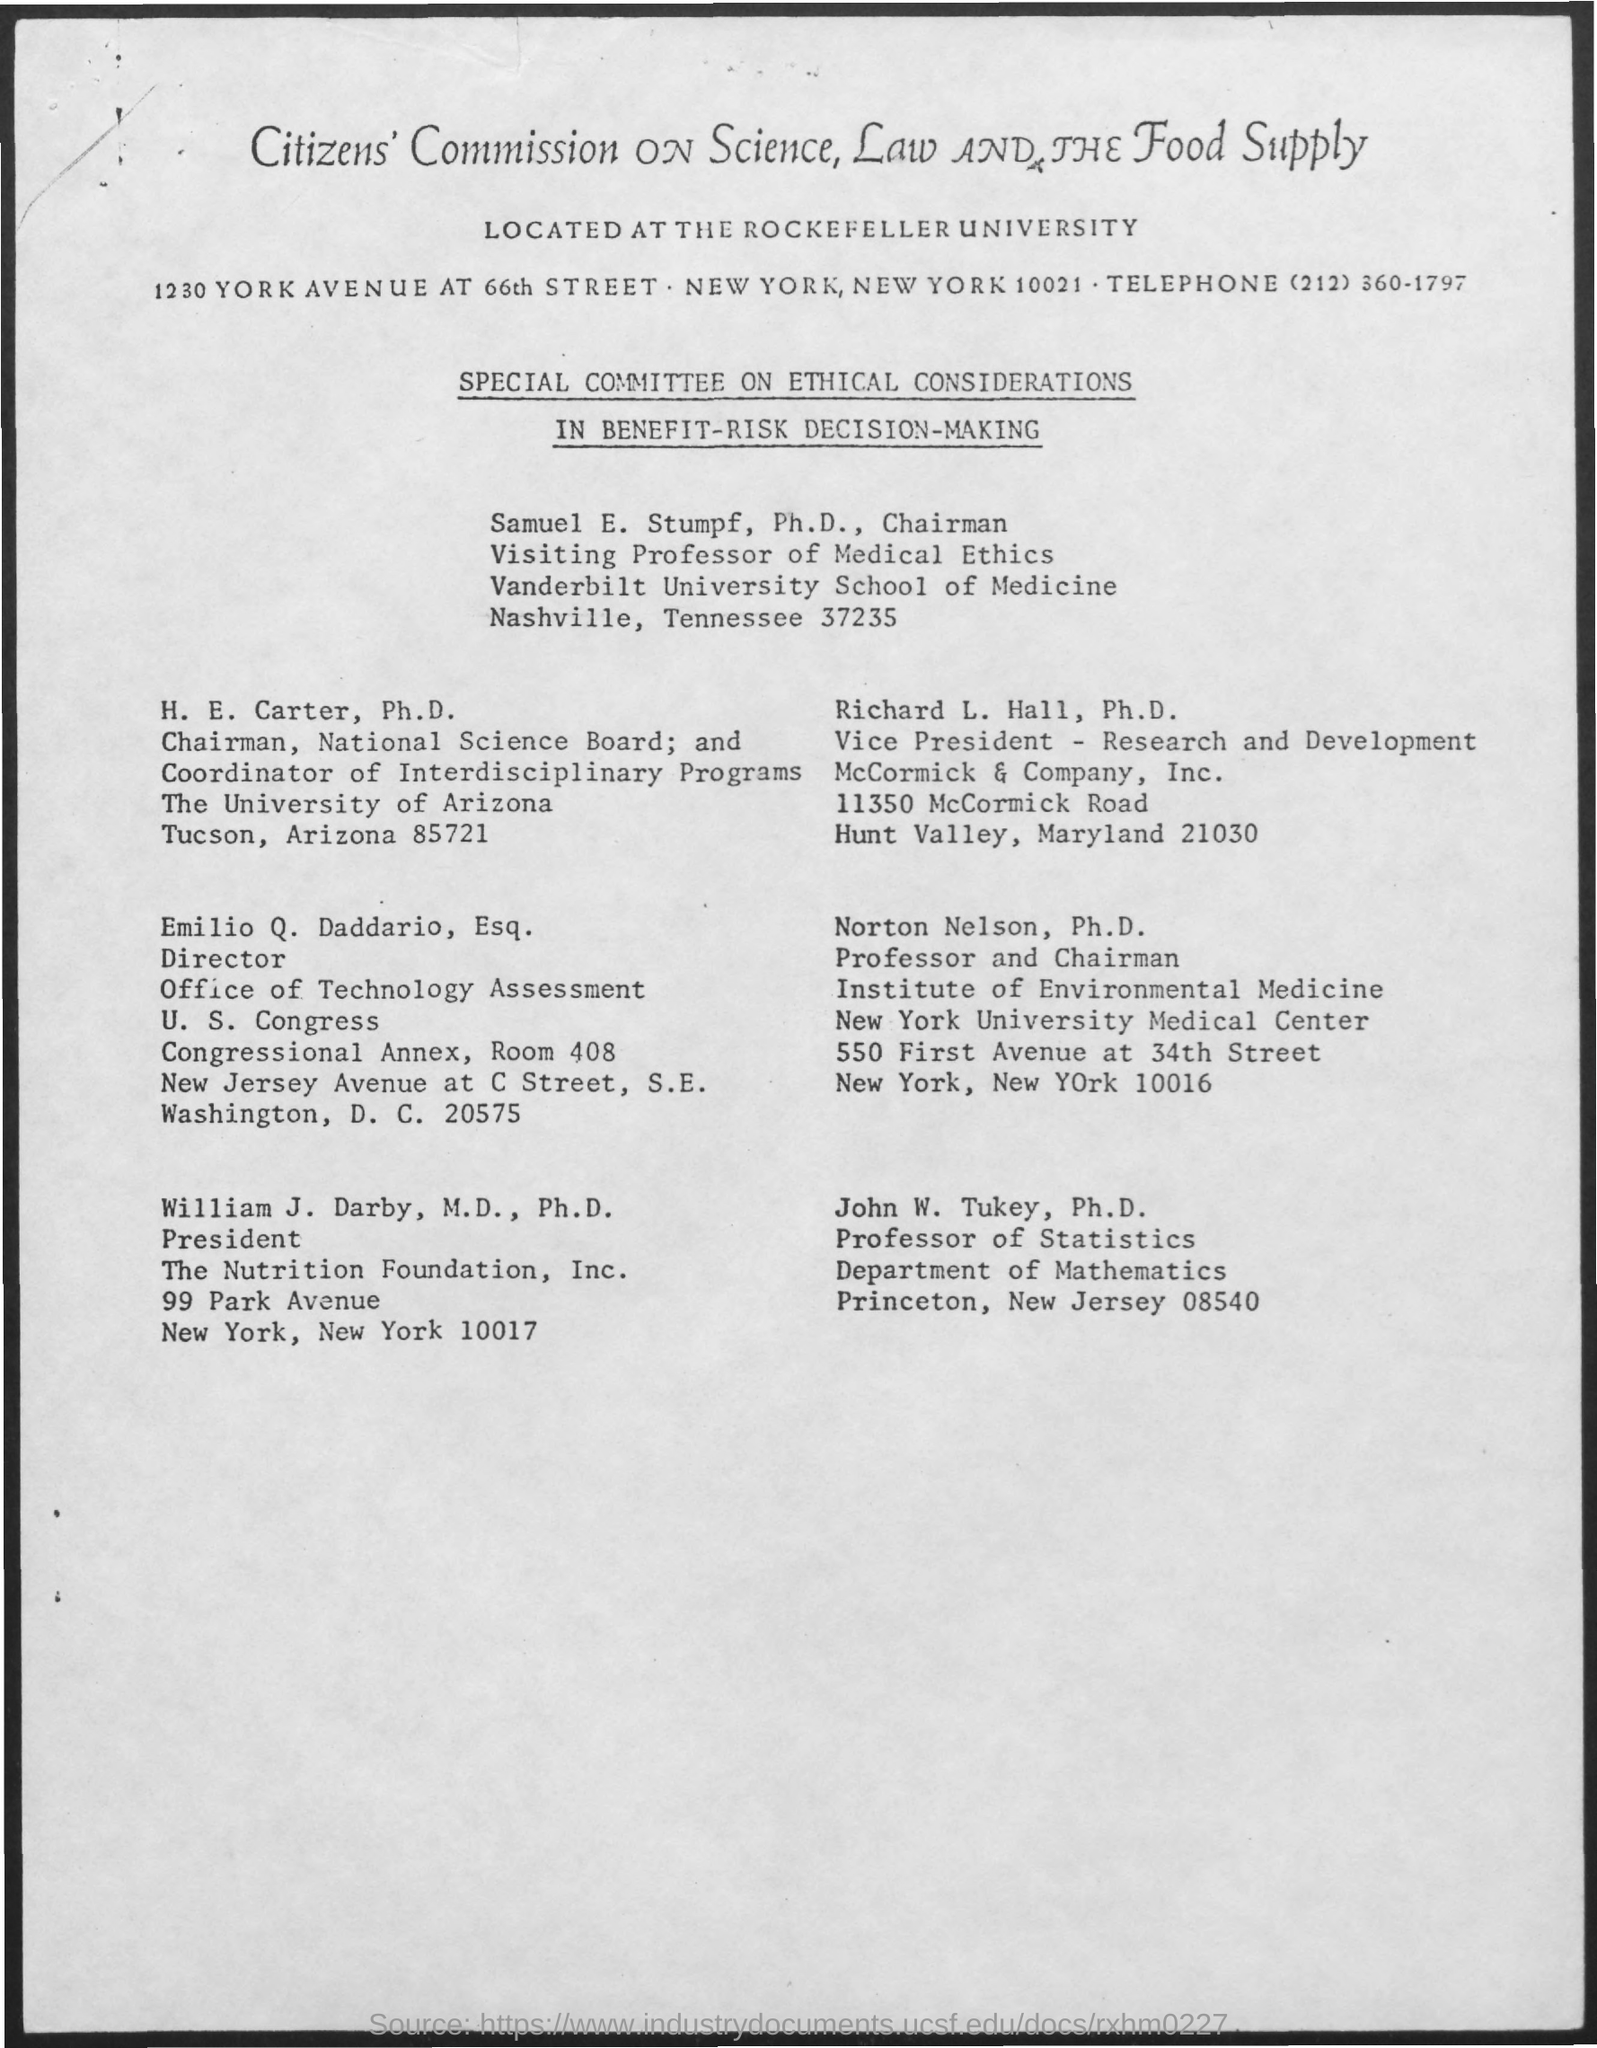Can you tell me more about the Citizens' Commission on Science, Law and the Food Supply mentioned in the document? The Citizens' Commission on Science, Law and the Food Supply appears to be an organization located at The Rockefeller University as stated in the document. This commission might focus on ethical considerations and decisions linked to the intersection of science, law, and food supply, aimed at guiding policy and research to improve health and safety standards. 